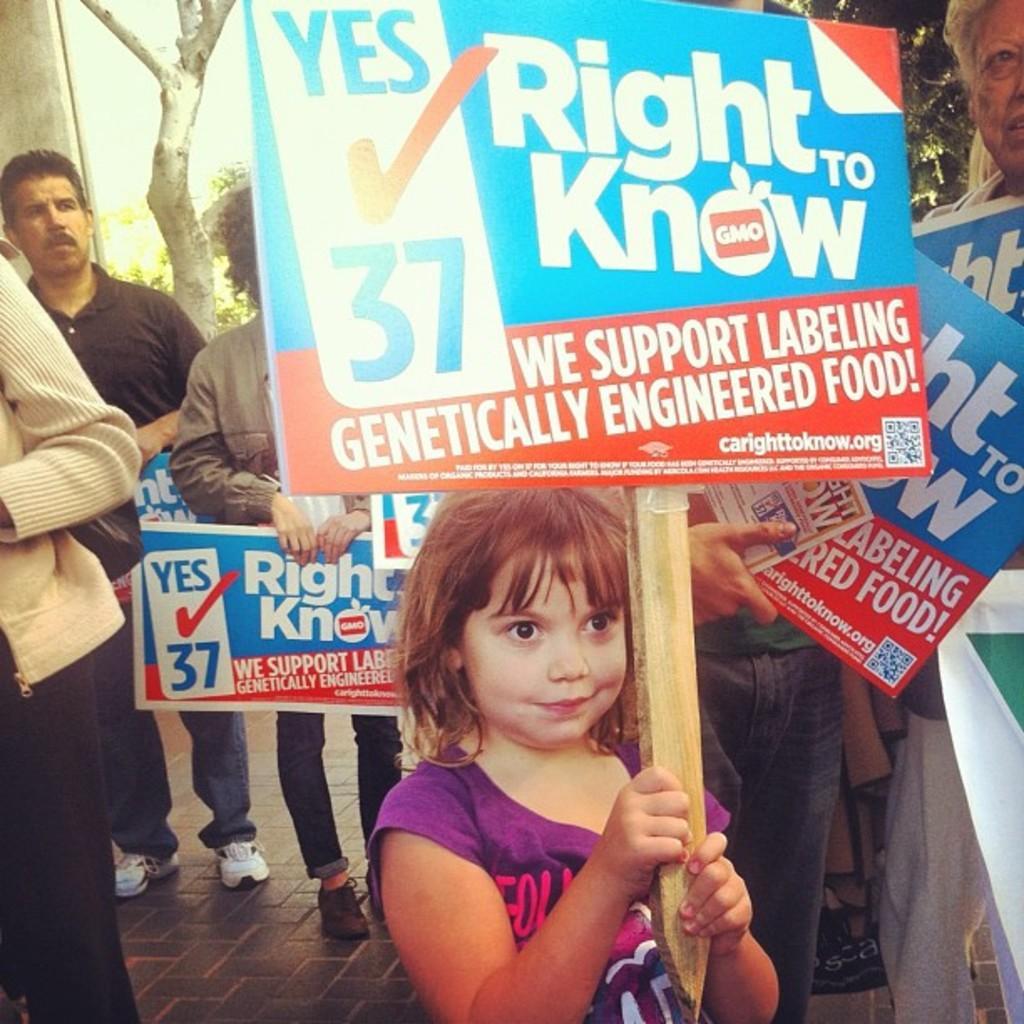In one or two sentences, can you explain what this image depicts? In this picture we can see people holding boards. We can see information on the boards. In the background we can see leaves and branches. On the left side of the picture we can see the partial part of a person. We can see a girl holding a stick. In the middle portion of the picture we can see a board is attached to a stick. She is smiling. 